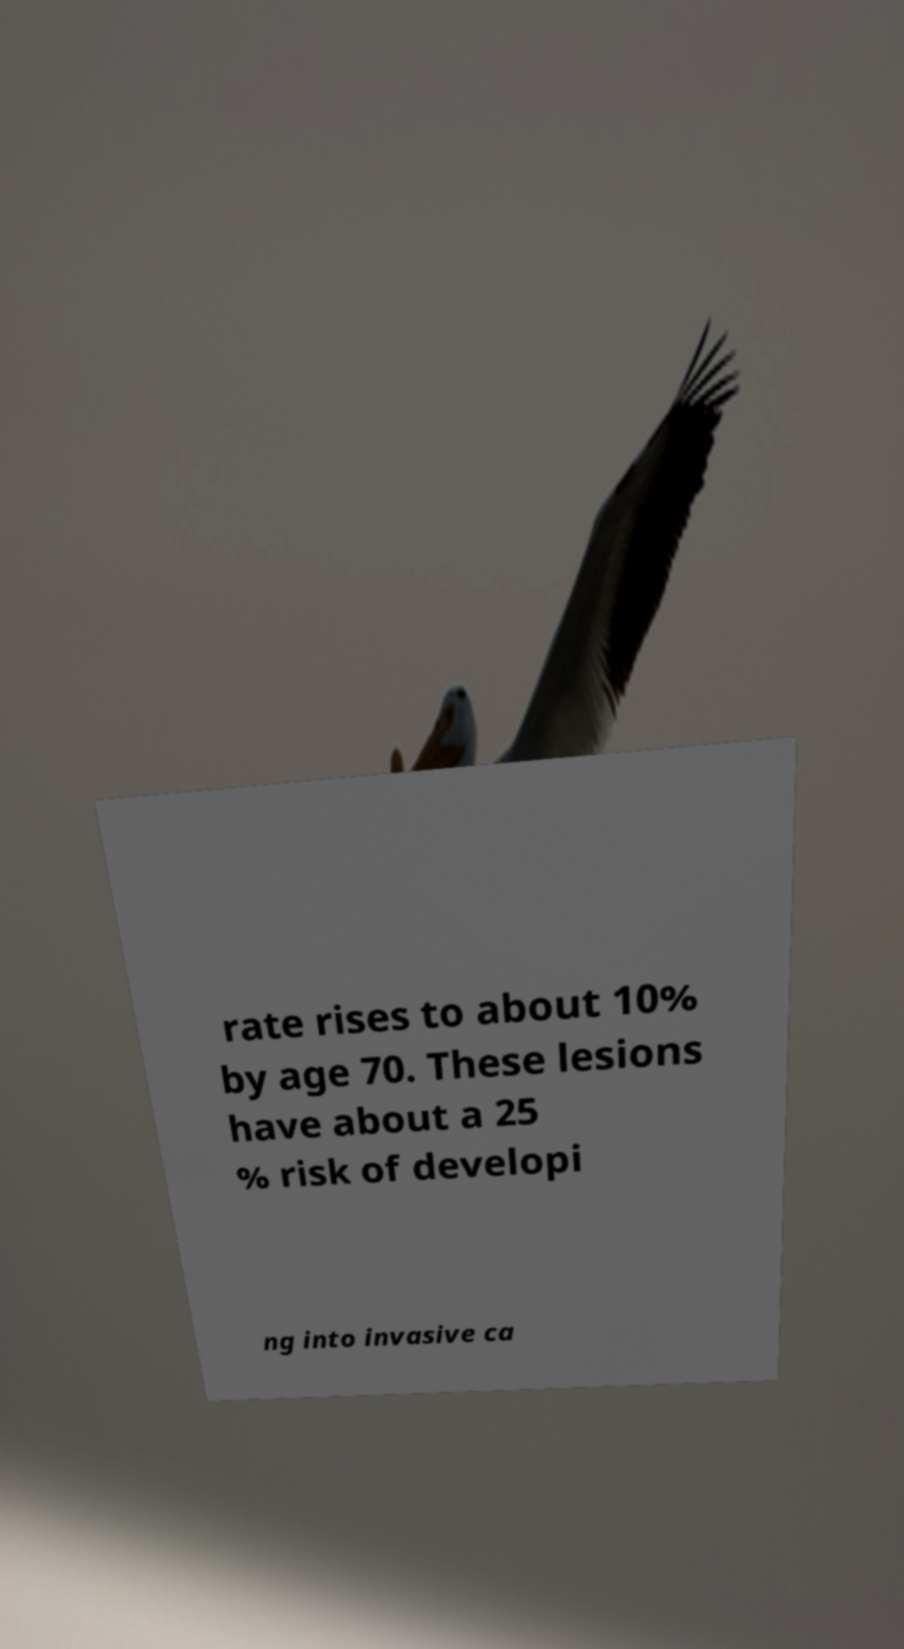Can you accurately transcribe the text from the provided image for me? rate rises to about 10% by age 70. These lesions have about a 25 % risk of developi ng into invasive ca 